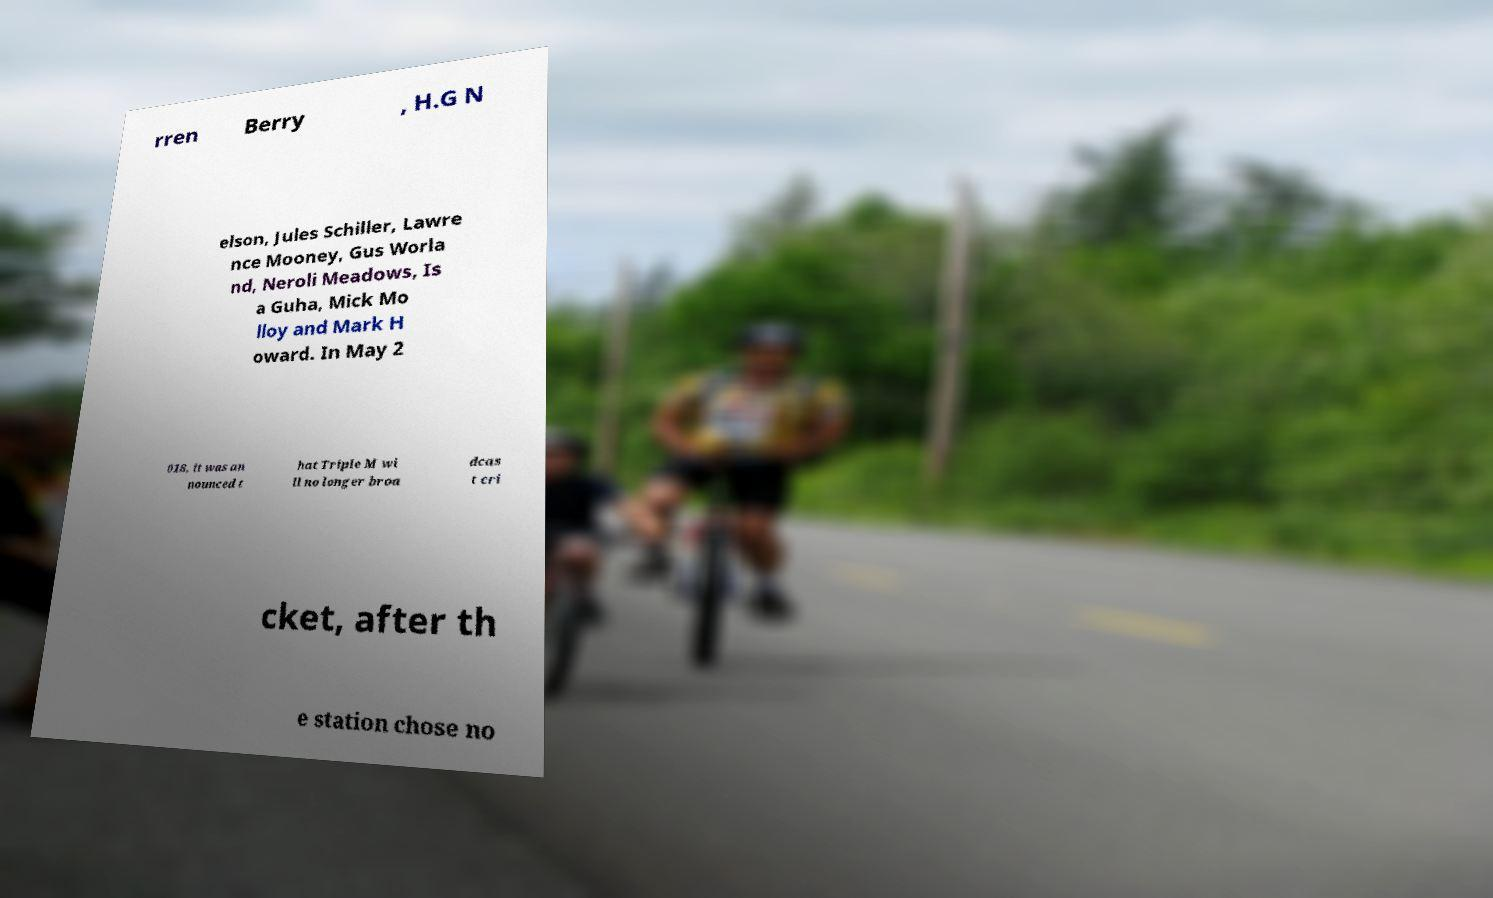Can you read and provide the text displayed in the image?This photo seems to have some interesting text. Can you extract and type it out for me? rren Berry , H.G N elson, Jules Schiller, Lawre nce Mooney, Gus Worla nd, Neroli Meadows, Is a Guha, Mick Mo lloy and Mark H oward. In May 2 018, it was an nounced t hat Triple M wi ll no longer broa dcas t cri cket, after th e station chose no 